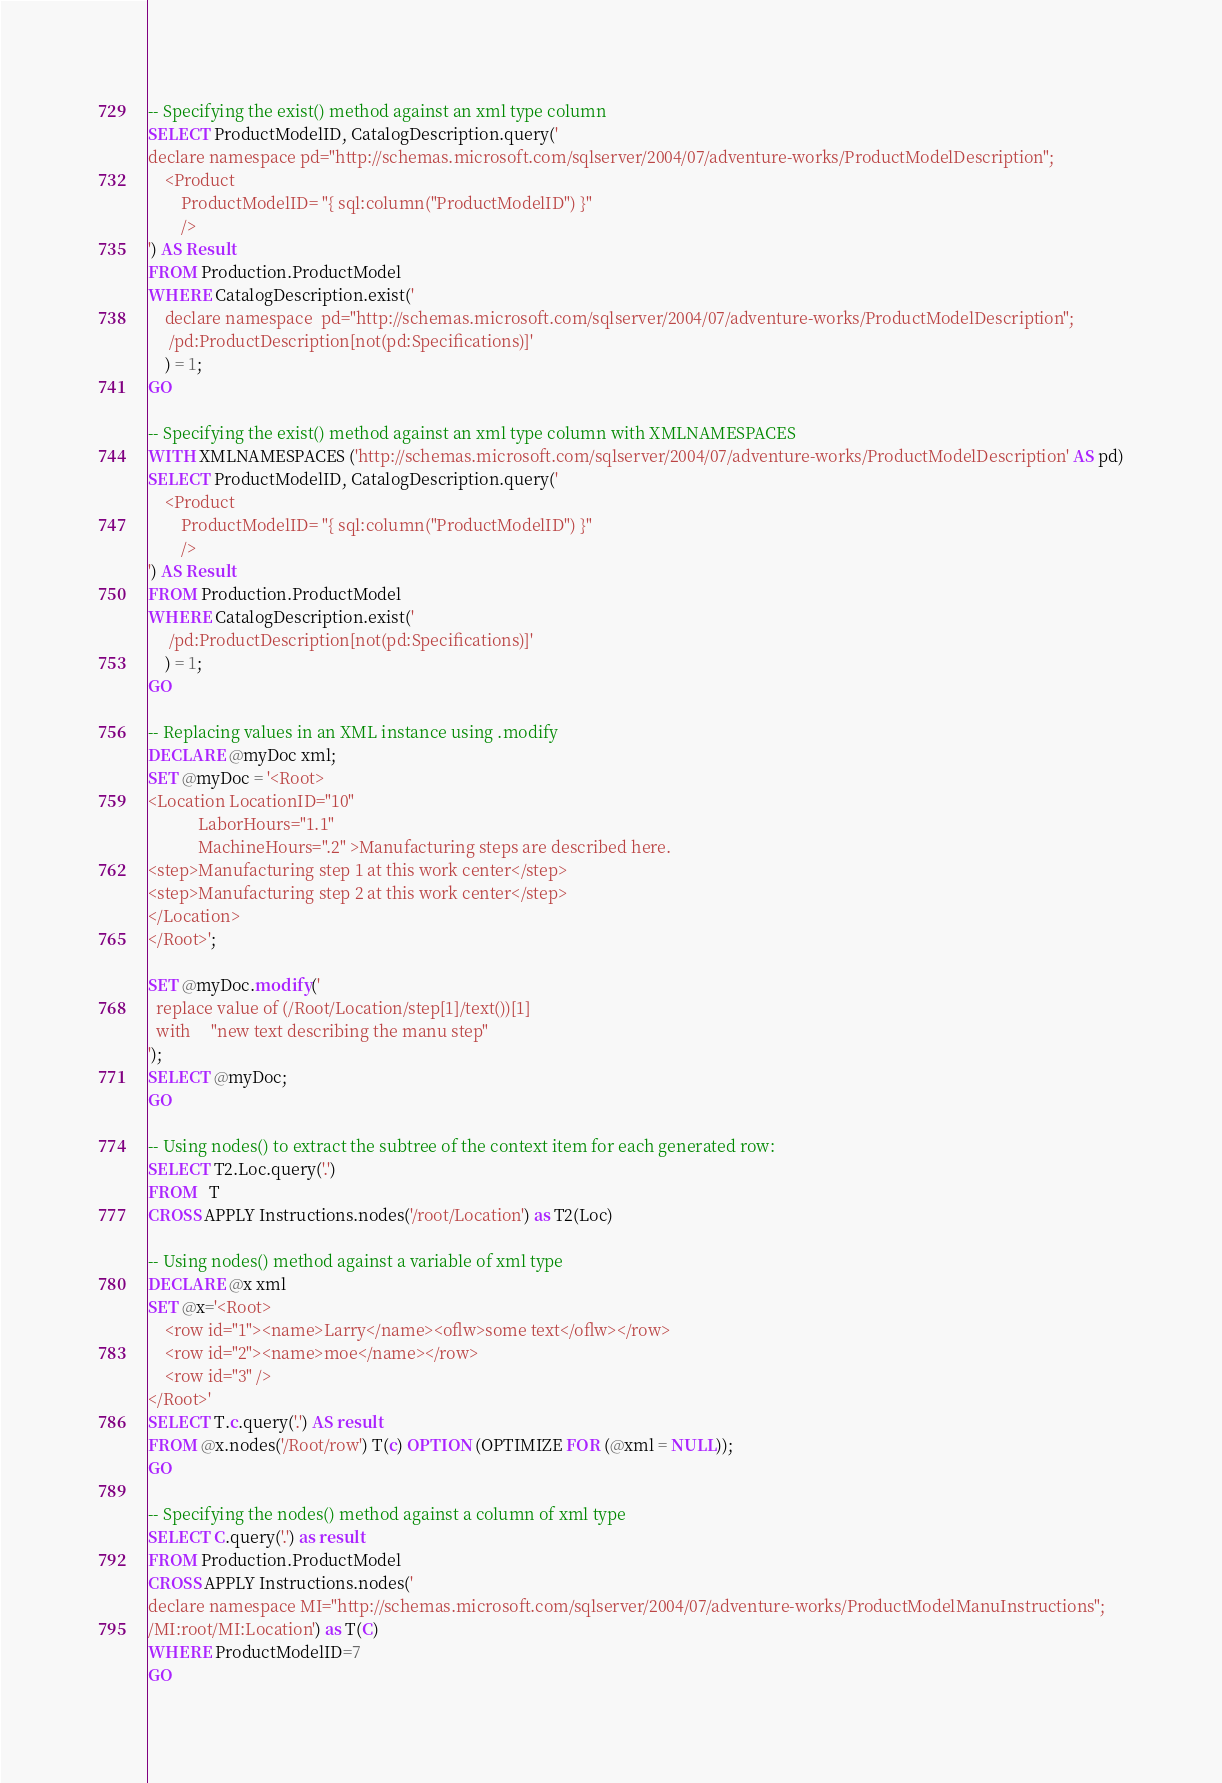Convert code to text. <code><loc_0><loc_0><loc_500><loc_500><_SQL_>
-- Specifying the exist() method against an xml type column
SELECT ProductModelID, CatalogDescription.query('
declare namespace pd="http://schemas.microsoft.com/sqlserver/2004/07/adventure-works/ProductModelDescription";
    <Product
        ProductModelID= "{ sql:column("ProductModelID") }"
        />
') AS Result
FROM Production.ProductModel
WHERE CatalogDescription.exist('
    declare namespace  pd="http://schemas.microsoft.com/sqlserver/2004/07/adventure-works/ProductModelDescription";
     /pd:ProductDescription[not(pd:Specifications)]'
    ) = 1;
GO

-- Specifying the exist() method against an xml type column with XMLNAMESPACES
WITH XMLNAMESPACES ('http://schemas.microsoft.com/sqlserver/2004/07/adventure-works/ProductModelDescription' AS pd)
SELECT ProductModelID, CatalogDescription.query('
    <Product
        ProductModelID= "{ sql:column("ProductModelID") }"
        />
') AS Result
FROM Production.ProductModel
WHERE CatalogDescription.exist('
     /pd:ProductDescription[not(pd:Specifications)]'
    ) = 1;
GO

-- Replacing values in an XML instance using .modify
DECLARE @myDoc xml;
SET @myDoc = '<Root>
<Location LocationID="10"
            LaborHours="1.1"
            MachineHours=".2" >Manufacturing steps are described here.
<step>Manufacturing step 1 at this work center</step>
<step>Manufacturing step 2 at this work center</step>
</Location>
</Root>';

SET @myDoc.modify('
  replace value of (/Root/Location/step[1]/text())[1]
  with     "new text describing the manu step"
');
SELECT @myDoc;
GO

-- Using nodes() to extract the subtree of the context item for each generated row:
SELECT T2.Loc.query('.')
FROM   T
CROSS APPLY Instructions.nodes('/root/Location') as T2(Loc)

-- Using nodes() method against a variable of xml type
DECLARE @x xml
SET @x='<Root>
    <row id="1"><name>Larry</name><oflw>some text</oflw></row>
    <row id="2"><name>moe</name></row>
    <row id="3" />
</Root>'
SELECT T.c.query('.') AS result
FROM @x.nodes('/Root/row') T(c) OPTION (OPTIMIZE FOR (@xml = NULL));
GO

-- Specifying the nodes() method against a column of xml type
SELECT C.query('.') as result
FROM Production.ProductModel
CROSS APPLY Instructions.nodes('
declare namespace MI="http://schemas.microsoft.com/sqlserver/2004/07/adventure-works/ProductModelManuInstructions";
/MI:root/MI:Location') as T(C)
WHERE ProductModelID=7
GO
</code> 